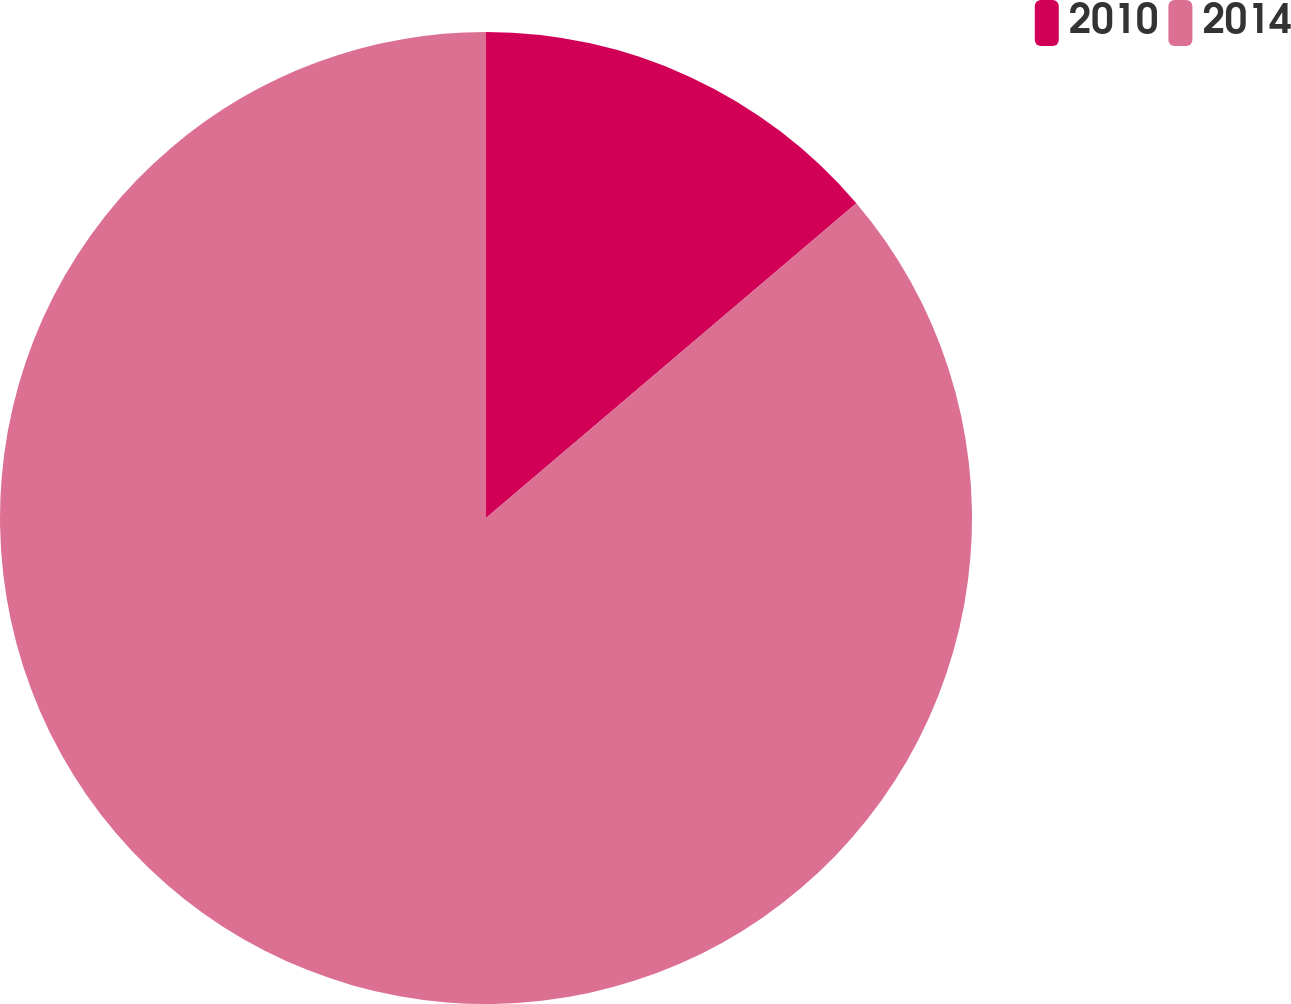Convert chart. <chart><loc_0><loc_0><loc_500><loc_500><pie_chart><fcel>2010<fcel>2014<nl><fcel>13.79%<fcel>86.21%<nl></chart> 